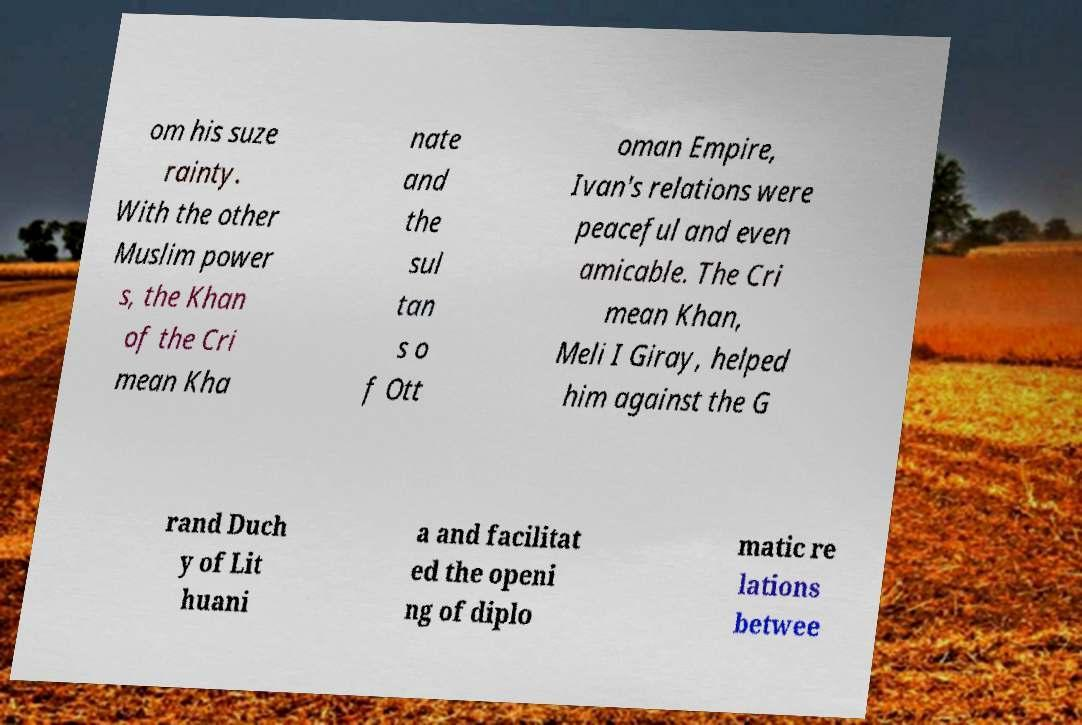What messages or text are displayed in this image? I need them in a readable, typed format. om his suze rainty. With the other Muslim power s, the Khan of the Cri mean Kha nate and the sul tan s o f Ott oman Empire, Ivan's relations were peaceful and even amicable. The Cri mean Khan, Meli I Giray, helped him against the G rand Duch y of Lit huani a and facilitat ed the openi ng of diplo matic re lations betwee 